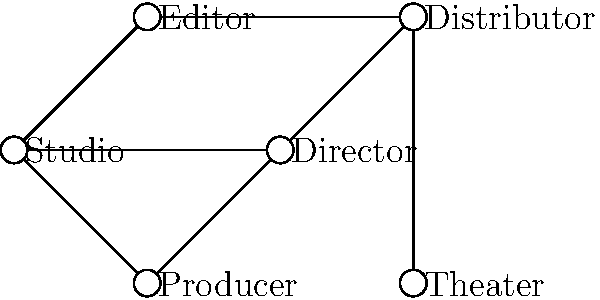In the network topology of Bodo film production and distribution shown above, which node has the highest degree centrality, and how does this impact the environmental footprint of the film industry? To answer this question, we need to follow these steps:

1. Understand degree centrality:
   Degree centrality is the number of direct connections a node has in a network.

2. Count the connections for each node:
   - Studio: 3 connections
   - Editor: 2 connections
   - Director: 2 connections
   - Producer: 2 connections
   - Distributor: 4 connections
   - Theater: 1 connection

3. Identify the node with the highest degree centrality:
   The Distributor has the highest degree centrality with 4 connections.

4. Consider the environmental impact:
   - The Distributor, being the most connected node, plays a crucial role in the network.
   - It acts as a central hub for film distribution, potentially increasing efficiency.
   - However, this centralization might lead to increased transportation and energy consumption.
   - From an environmental perspective, this could result in:
     a) Higher carbon emissions due to extensive distribution networks.
     b) Increased energy use for digital distribution and storage.
     c) Potential for optimizing distribution routes and methods to reduce environmental impact.

5. Relate to Bodo film industry:
   - As a growing regional film industry, Bodo films can use this centralized distribution to:
     a) Implement eco-friendly distribution practices.
     b) Promote local screenings to reduce transportation.
     c) Utilize digital distribution to minimize physical media production.

The Distributor's high centrality offers both challenges and opportunities for reducing the environmental footprint of the Bodo film industry.
Answer: Distributor; central role allows for both increased efficiency and potential environmental impact, offering opportunities for eco-friendly practices in Bodo film distribution. 